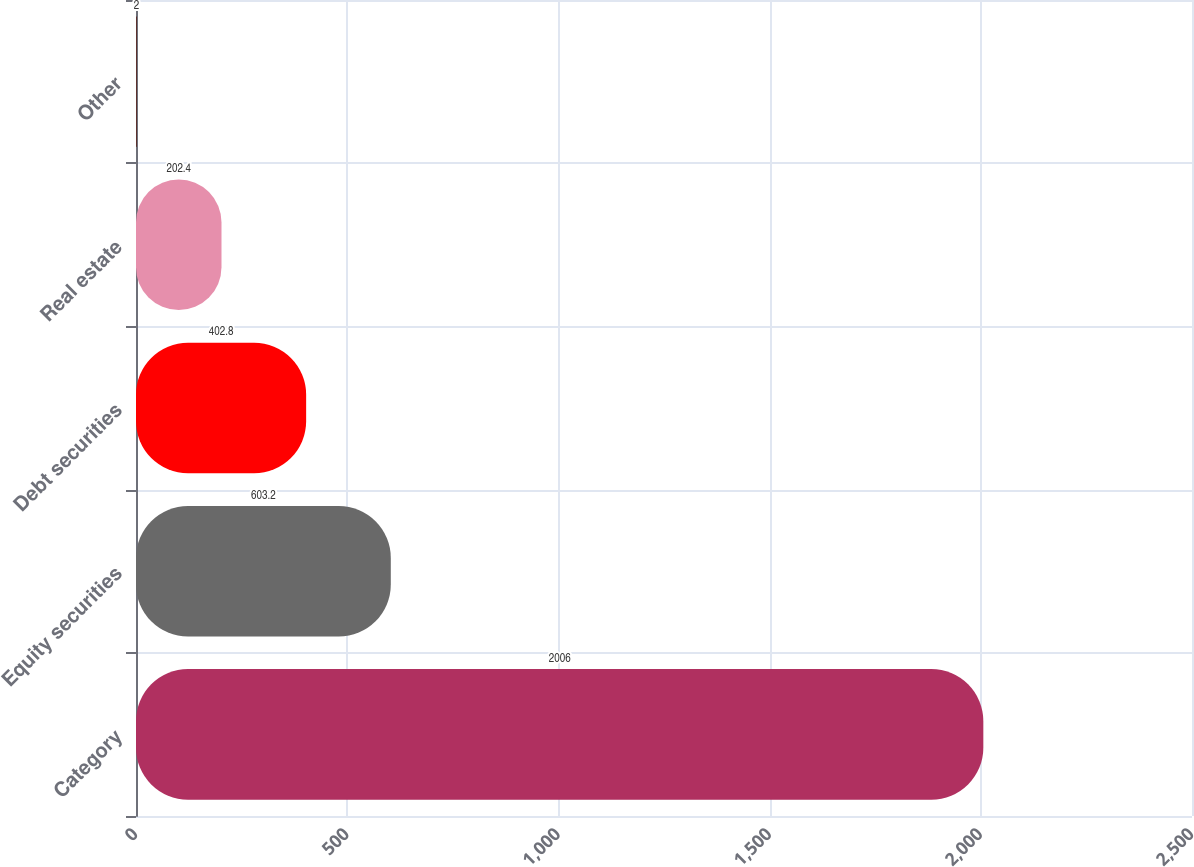<chart> <loc_0><loc_0><loc_500><loc_500><bar_chart><fcel>Category<fcel>Equity securities<fcel>Debt securities<fcel>Real estate<fcel>Other<nl><fcel>2006<fcel>603.2<fcel>402.8<fcel>202.4<fcel>2<nl></chart> 